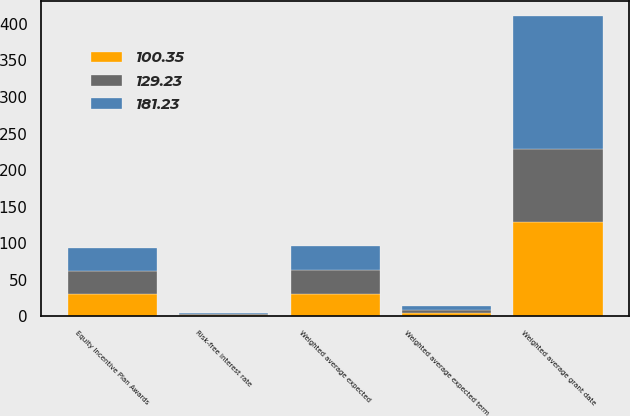<chart> <loc_0><loc_0><loc_500><loc_500><stacked_bar_chart><ecel><fcel>Equity Incentive Plan Awards<fcel>Weighted average expected term<fcel>Weighted average expected<fcel>Risk-free interest rate<fcel>Weighted average grant date<nl><fcel>181.23<fcel>31.3<fcel>4.9<fcel>33.7<fcel>1.81<fcel>181.23<nl><fcel>129.23<fcel>31.3<fcel>4.8<fcel>31.7<fcel>1.32<fcel>100.35<nl><fcel>100.35<fcel>31.3<fcel>4.7<fcel>31.3<fcel>1.49<fcel>129.23<nl></chart> 